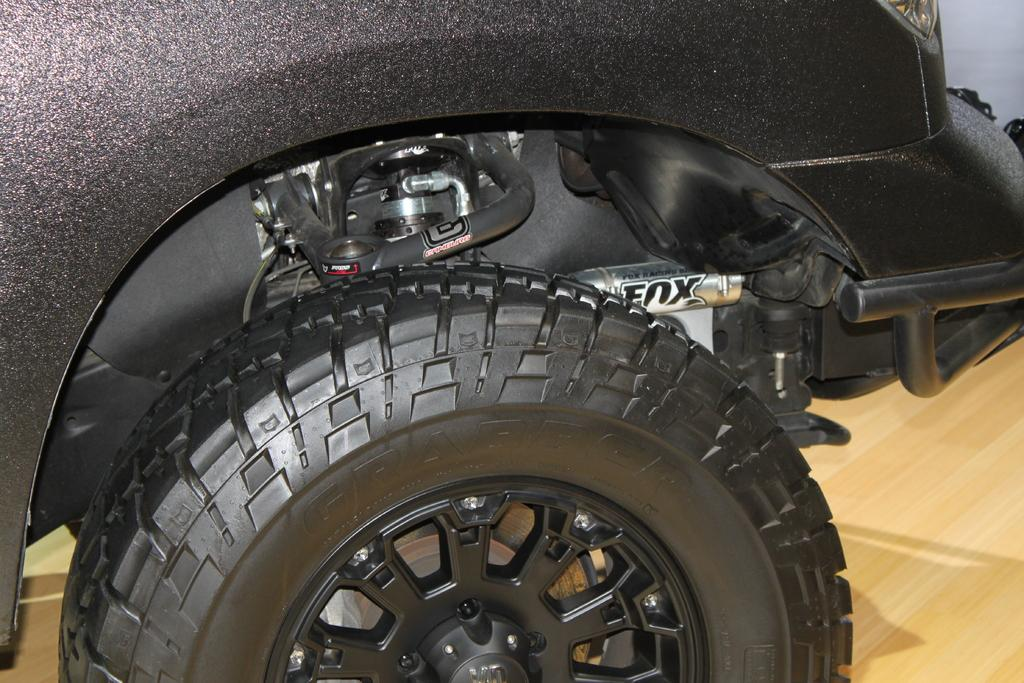What type of vehicle is partially visible in the image? There is a part of a car in the image. What specific part of the car can be seen? The image only shows a tire of the car. Can you describe the position of the tire in the image? The tire is placed on a surface. What type of furniture is supporting the neck of the giant in the image? There are no giants or furniture present in the image; it only features a part of a car and a tire. 